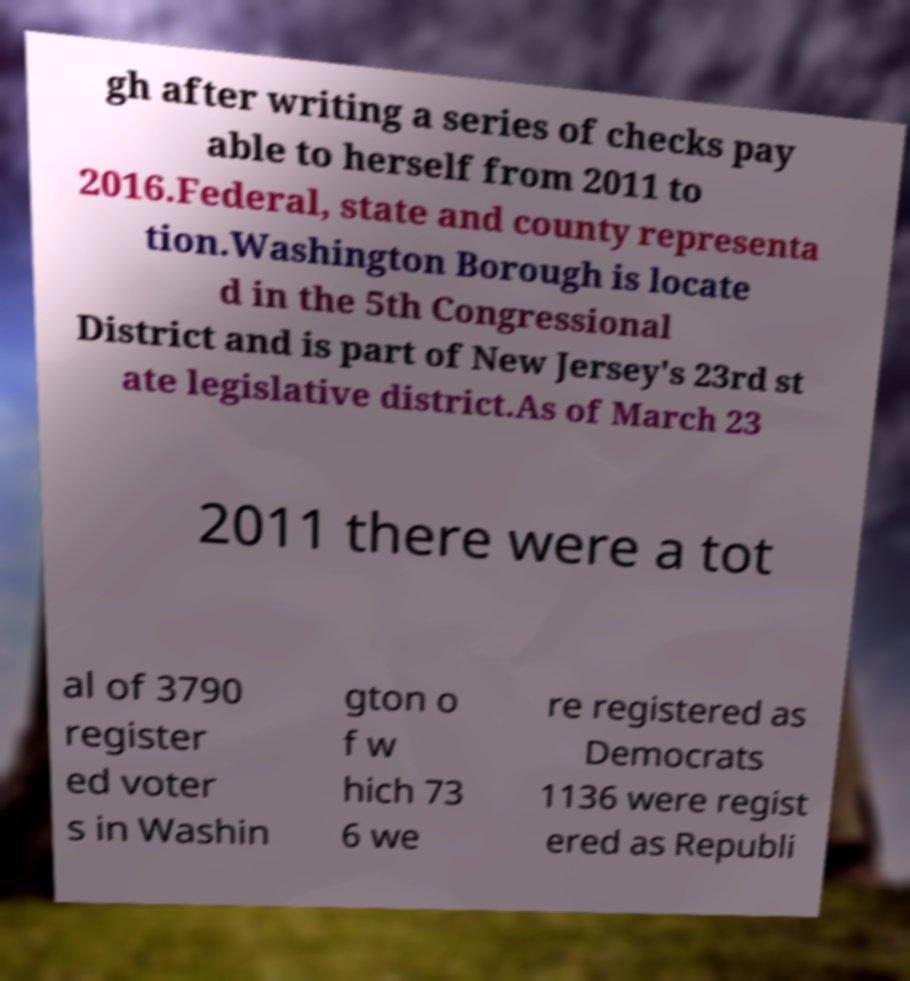I need the written content from this picture converted into text. Can you do that? gh after writing a series of checks pay able to herself from 2011 to 2016.Federal, state and county representa tion.Washington Borough is locate d in the 5th Congressional District and is part of New Jersey's 23rd st ate legislative district.As of March 23 2011 there were a tot al of 3790 register ed voter s in Washin gton o f w hich 73 6 we re registered as Democrats 1136 were regist ered as Republi 